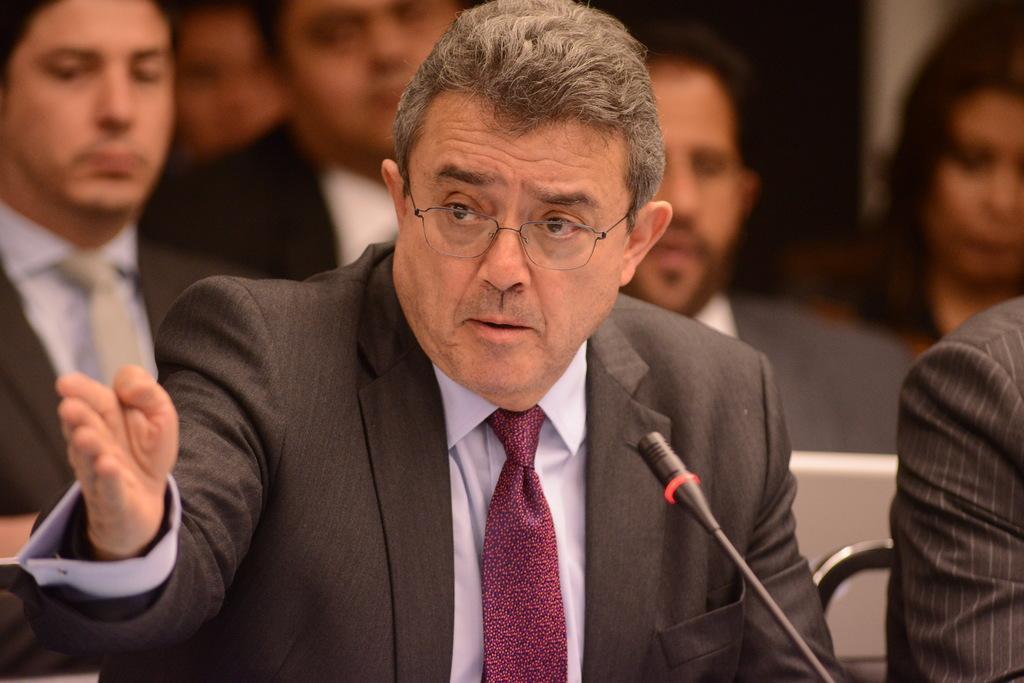How would you summarize this image in a sentence or two? In the foreground of the picture there is a person wearing suit, in front of in there is a mic. On the right there is another person's hand and chair. In the background there are people. The background is blurred. 